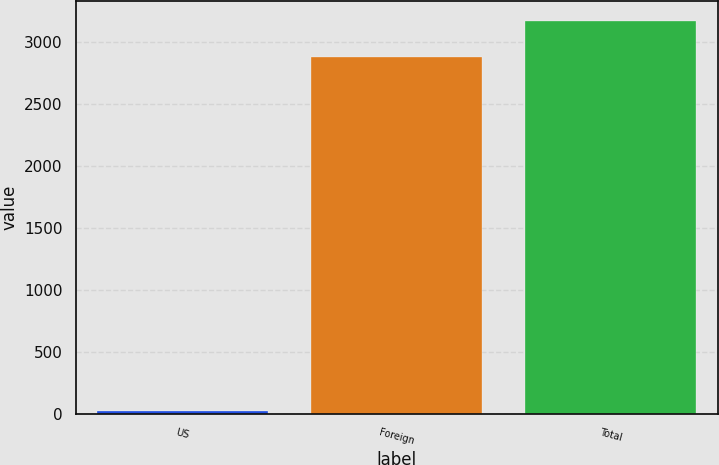Convert chart to OTSL. <chart><loc_0><loc_0><loc_500><loc_500><bar_chart><fcel>US<fcel>Foreign<fcel>Total<nl><fcel>20<fcel>2882<fcel>3170.2<nl></chart> 